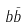Convert formula to latex. <formula><loc_0><loc_0><loc_500><loc_500>b { \bar { b } }</formula> 